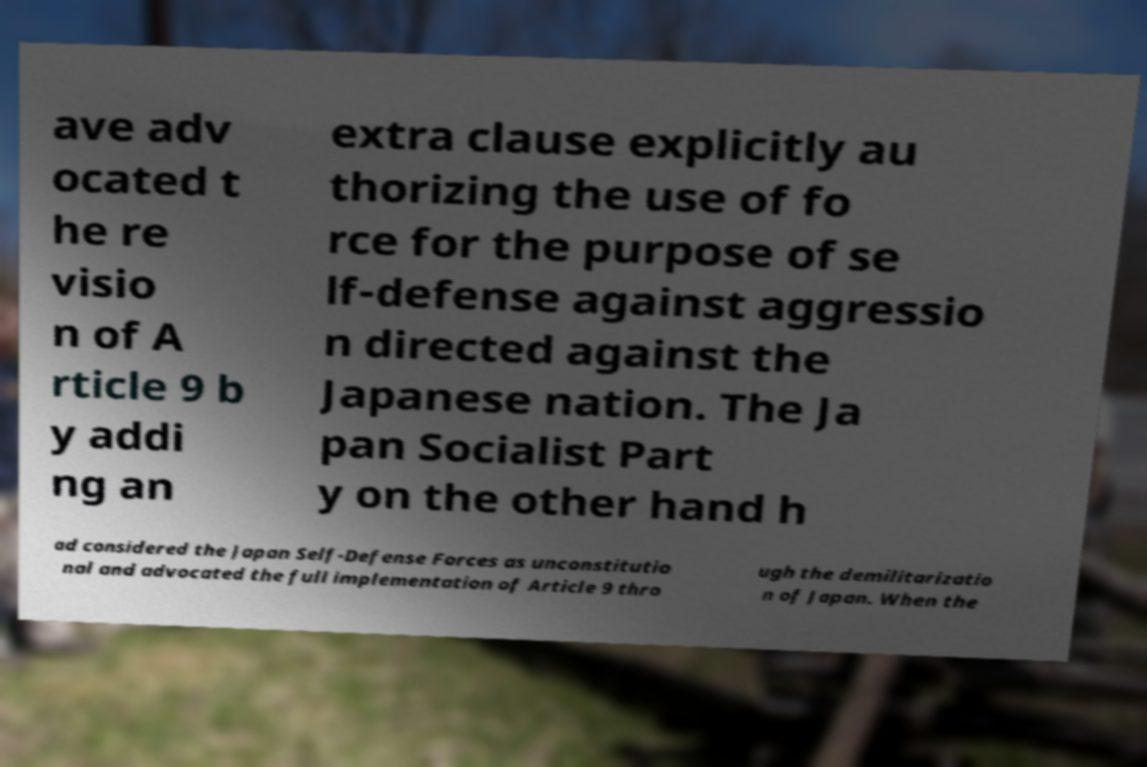There's text embedded in this image that I need extracted. Can you transcribe it verbatim? ave adv ocated t he re visio n of A rticle 9 b y addi ng an extra clause explicitly au thorizing the use of fo rce for the purpose of se lf-defense against aggressio n directed against the Japanese nation. The Ja pan Socialist Part y on the other hand h ad considered the Japan Self-Defense Forces as unconstitutio nal and advocated the full implementation of Article 9 thro ugh the demilitarizatio n of Japan. When the 